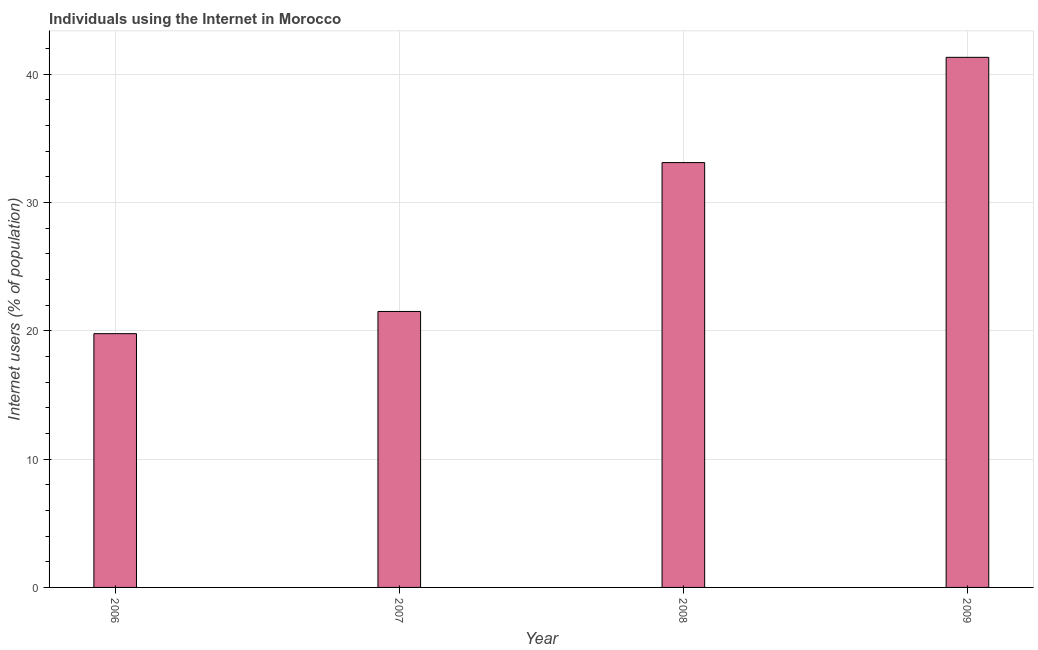What is the title of the graph?
Your answer should be very brief. Individuals using the Internet in Morocco. What is the label or title of the X-axis?
Keep it short and to the point. Year. What is the label or title of the Y-axis?
Give a very brief answer. Internet users (% of population). What is the number of internet users in 2007?
Your response must be concise. 21.5. Across all years, what is the maximum number of internet users?
Your response must be concise. 41.3. Across all years, what is the minimum number of internet users?
Your answer should be very brief. 19.77. In which year was the number of internet users minimum?
Provide a succinct answer. 2006. What is the sum of the number of internet users?
Make the answer very short. 115.67. What is the difference between the number of internet users in 2007 and 2008?
Provide a succinct answer. -11.6. What is the average number of internet users per year?
Offer a very short reply. 28.92. What is the median number of internet users?
Provide a short and direct response. 27.3. In how many years, is the number of internet users greater than 38 %?
Your answer should be compact. 1. Do a majority of the years between 2008 and 2007 (inclusive) have number of internet users greater than 12 %?
Provide a short and direct response. No. What is the ratio of the number of internet users in 2008 to that in 2009?
Give a very brief answer. 0.8. Is the number of internet users in 2007 less than that in 2009?
Give a very brief answer. Yes. What is the difference between the highest and the second highest number of internet users?
Give a very brief answer. 8.2. Is the sum of the number of internet users in 2006 and 2007 greater than the maximum number of internet users across all years?
Provide a succinct answer. No. What is the difference between the highest and the lowest number of internet users?
Make the answer very short. 21.53. In how many years, is the number of internet users greater than the average number of internet users taken over all years?
Give a very brief answer. 2. How many bars are there?
Your answer should be compact. 4. What is the difference between two consecutive major ticks on the Y-axis?
Your answer should be very brief. 10. What is the Internet users (% of population) of 2006?
Give a very brief answer. 19.77. What is the Internet users (% of population) in 2007?
Your answer should be very brief. 21.5. What is the Internet users (% of population) in 2008?
Your answer should be compact. 33.1. What is the Internet users (% of population) in 2009?
Your answer should be compact. 41.3. What is the difference between the Internet users (% of population) in 2006 and 2007?
Provide a short and direct response. -1.73. What is the difference between the Internet users (% of population) in 2006 and 2008?
Give a very brief answer. -13.33. What is the difference between the Internet users (% of population) in 2006 and 2009?
Give a very brief answer. -21.53. What is the difference between the Internet users (% of population) in 2007 and 2009?
Ensure brevity in your answer.  -19.8. What is the difference between the Internet users (% of population) in 2008 and 2009?
Provide a short and direct response. -8.2. What is the ratio of the Internet users (% of population) in 2006 to that in 2007?
Ensure brevity in your answer.  0.92. What is the ratio of the Internet users (% of population) in 2006 to that in 2008?
Offer a terse response. 0.6. What is the ratio of the Internet users (% of population) in 2006 to that in 2009?
Offer a terse response. 0.48. What is the ratio of the Internet users (% of population) in 2007 to that in 2008?
Provide a succinct answer. 0.65. What is the ratio of the Internet users (% of population) in 2007 to that in 2009?
Your answer should be very brief. 0.52. What is the ratio of the Internet users (% of population) in 2008 to that in 2009?
Give a very brief answer. 0.8. 